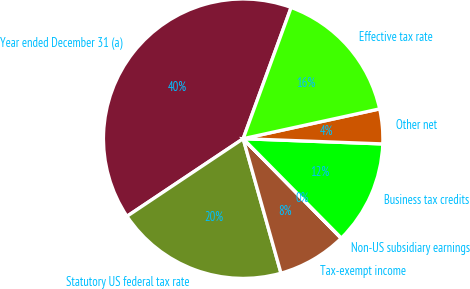Convert chart to OTSL. <chart><loc_0><loc_0><loc_500><loc_500><pie_chart><fcel>Year ended December 31 (a)<fcel>Statutory US federal tax rate<fcel>Tax-exempt income<fcel>Non-US subsidiary earnings<fcel>Business tax credits<fcel>Other net<fcel>Effective tax rate<nl><fcel>39.95%<fcel>19.99%<fcel>8.01%<fcel>0.03%<fcel>12.0%<fcel>4.02%<fcel>16.0%<nl></chart> 